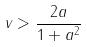Convert formula to latex. <formula><loc_0><loc_0><loc_500><loc_500>v > \frac { 2 a } { 1 + a ^ { 2 } }</formula> 